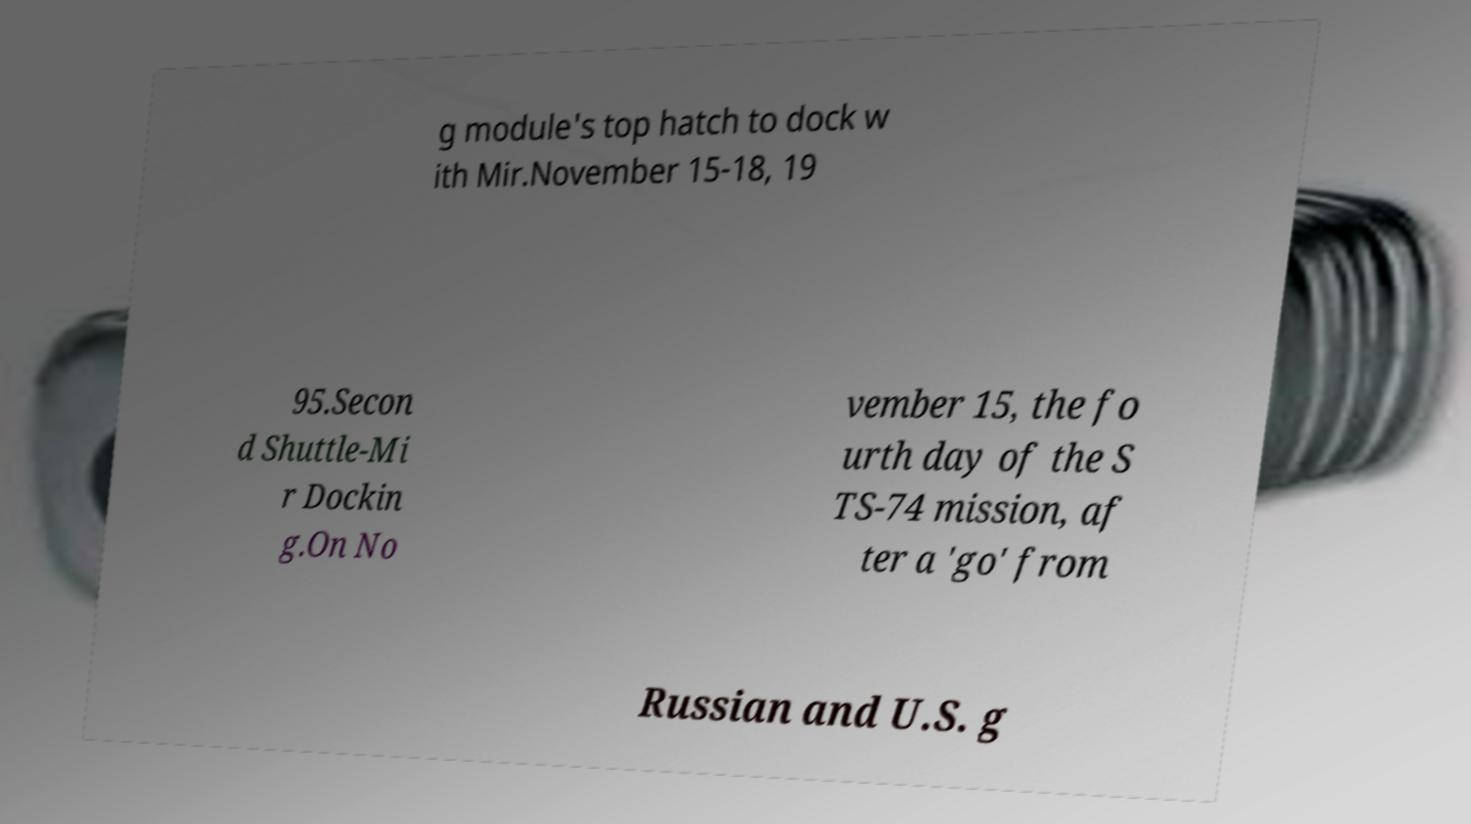I need the written content from this picture converted into text. Can you do that? g module's top hatch to dock w ith Mir.November 15-18, 19 95.Secon d Shuttle-Mi r Dockin g.On No vember 15, the fo urth day of the S TS-74 mission, af ter a 'go' from Russian and U.S. g 